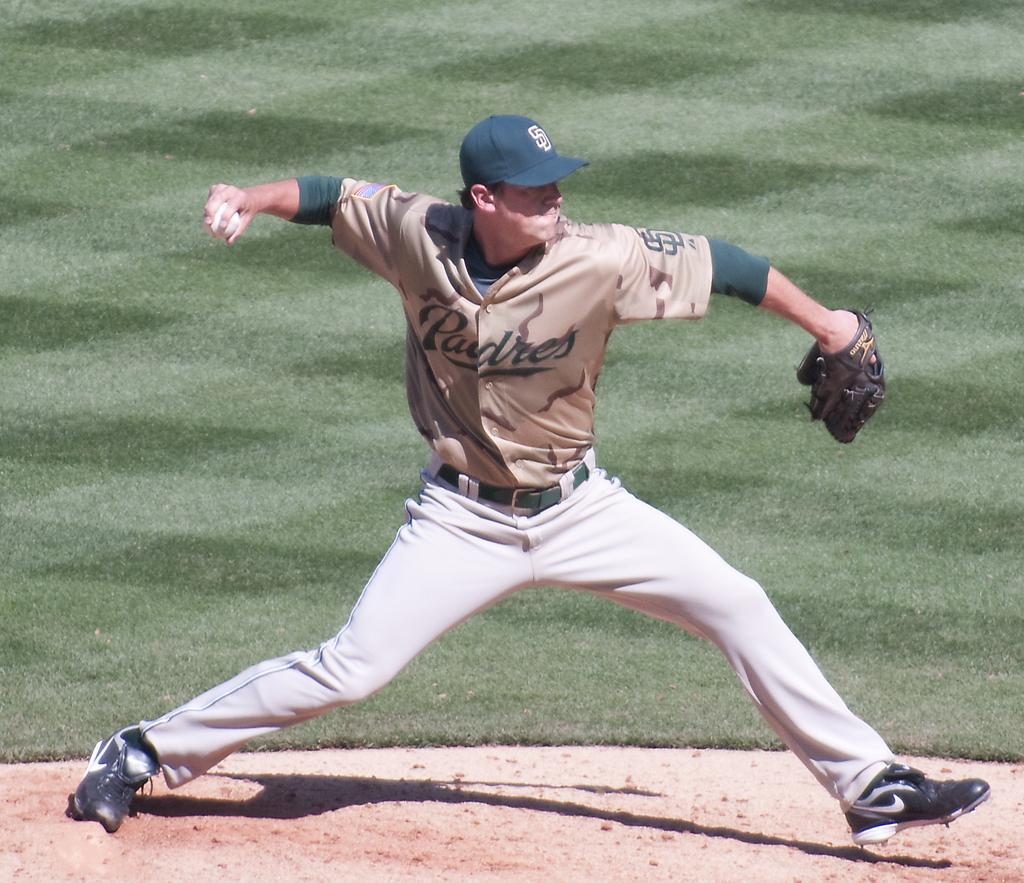Provide a one-sentence caption for the provided image. A Padres Baseball Pitcher winds up for the Pitch. 